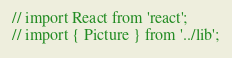Convert code to text. <code><loc_0><loc_0><loc_500><loc_500><_JavaScript_>// import React from 'react';
// import { Picture } from '../lib';
</code> 